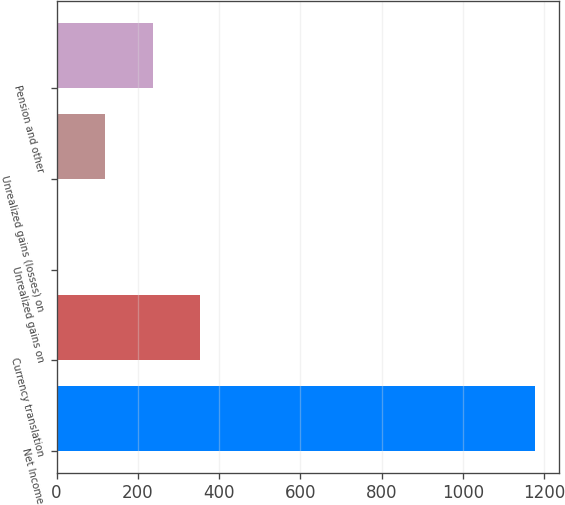<chart> <loc_0><loc_0><loc_500><loc_500><bar_chart><fcel>Net Income<fcel>Currency translation<fcel>Unrealized gains on<fcel>Unrealized gains (losses) on<fcel>Pension and other<nl><fcel>1177.9<fcel>353.86<fcel>0.7<fcel>118.42<fcel>236.14<nl></chart> 